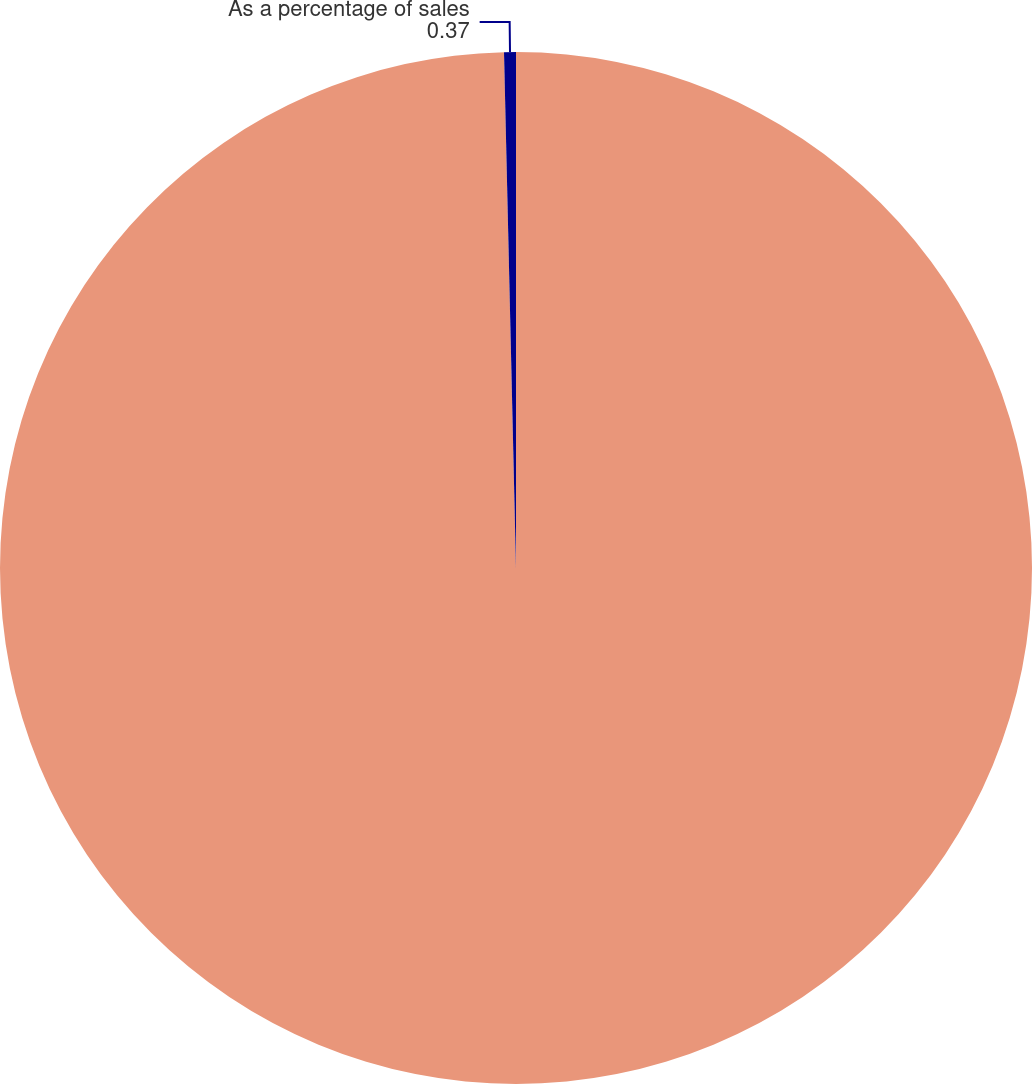<chart> <loc_0><loc_0><loc_500><loc_500><pie_chart><fcel>Selling general and<fcel>As a percentage of sales<nl><fcel>99.63%<fcel>0.37%<nl></chart> 